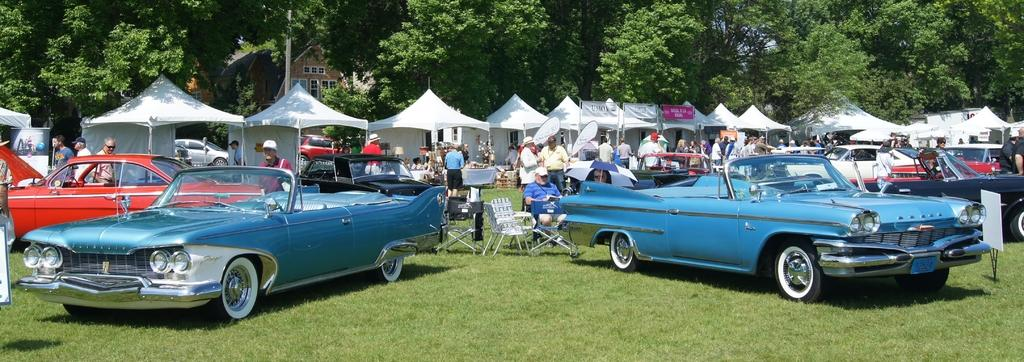What can be seen in the middle of the image? There are cars and tents in the middle of the image. What objects are present for people to sit on? There are chairs in the image, and people are sitting on them. What type of vegetation is visible at the top of the image? There are trees at the top of the image. Can you tell me how many girls are standing next to the giraffe in the image? There is no girl or giraffe present in the image. What type of camp can be seen in the image? The image does not depict a camp; it shows cars, tents, chairs, and people sitting on chairs. 